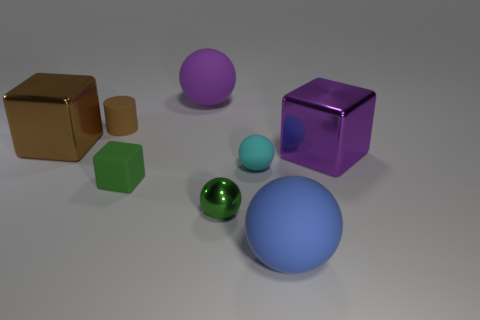Subtract 1 balls. How many balls are left? 3 Add 1 big cubes. How many objects exist? 9 Subtract all blocks. How many objects are left? 5 Subtract 0 red cylinders. How many objects are left? 8 Subtract all yellow metallic cubes. Subtract all large purple metallic things. How many objects are left? 7 Add 6 purple things. How many purple things are left? 8 Add 8 big gray spheres. How many big gray spheres exist? 8 